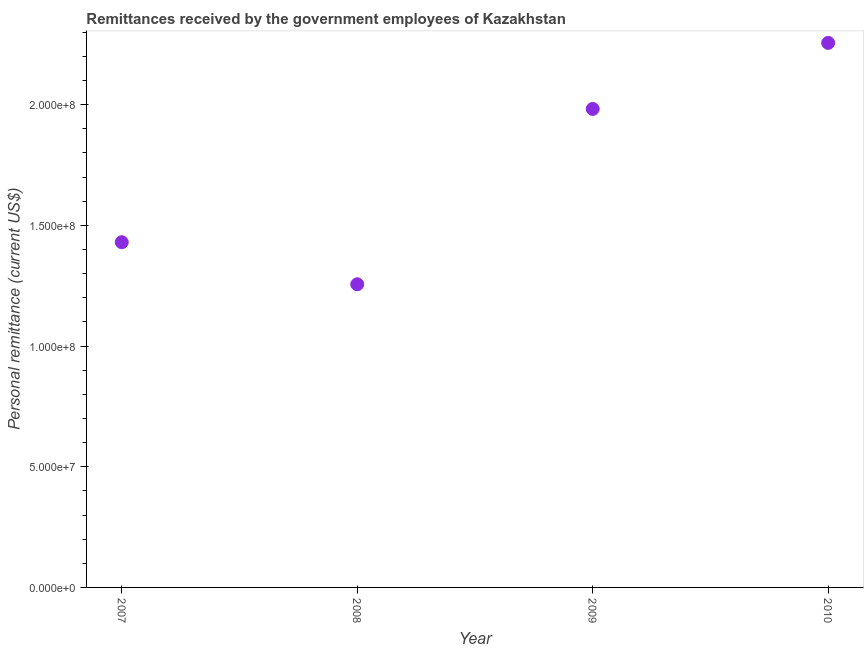What is the personal remittances in 2007?
Keep it short and to the point. 1.43e+08. Across all years, what is the maximum personal remittances?
Your answer should be very brief. 2.26e+08. Across all years, what is the minimum personal remittances?
Your answer should be very brief. 1.26e+08. What is the sum of the personal remittances?
Make the answer very short. 6.92e+08. What is the difference between the personal remittances in 2007 and 2010?
Provide a succinct answer. -8.26e+07. What is the average personal remittances per year?
Ensure brevity in your answer.  1.73e+08. What is the median personal remittances?
Your answer should be compact. 1.71e+08. In how many years, is the personal remittances greater than 80000000 US$?
Make the answer very short. 4. Do a majority of the years between 2009 and 2007 (inclusive) have personal remittances greater than 160000000 US$?
Your response must be concise. No. What is the ratio of the personal remittances in 2008 to that in 2010?
Provide a short and direct response. 0.56. What is the difference between the highest and the second highest personal remittances?
Offer a very short reply. 2.74e+07. Is the sum of the personal remittances in 2007 and 2009 greater than the maximum personal remittances across all years?
Your response must be concise. Yes. What is the difference between the highest and the lowest personal remittances?
Keep it short and to the point. 1.00e+08. Does the personal remittances monotonically increase over the years?
Ensure brevity in your answer.  No. How many years are there in the graph?
Provide a succinct answer. 4. What is the difference between two consecutive major ticks on the Y-axis?
Provide a short and direct response. 5.00e+07. Are the values on the major ticks of Y-axis written in scientific E-notation?
Provide a succinct answer. Yes. Does the graph contain grids?
Your answer should be compact. No. What is the title of the graph?
Make the answer very short. Remittances received by the government employees of Kazakhstan. What is the label or title of the X-axis?
Make the answer very short. Year. What is the label or title of the Y-axis?
Offer a very short reply. Personal remittance (current US$). What is the Personal remittance (current US$) in 2007?
Ensure brevity in your answer.  1.43e+08. What is the Personal remittance (current US$) in 2008?
Your answer should be very brief. 1.26e+08. What is the Personal remittance (current US$) in 2009?
Your answer should be very brief. 1.98e+08. What is the Personal remittance (current US$) in 2010?
Provide a short and direct response. 2.26e+08. What is the difference between the Personal remittance (current US$) in 2007 and 2008?
Your answer should be compact. 1.74e+07. What is the difference between the Personal remittance (current US$) in 2007 and 2009?
Offer a terse response. -5.52e+07. What is the difference between the Personal remittance (current US$) in 2007 and 2010?
Give a very brief answer. -8.26e+07. What is the difference between the Personal remittance (current US$) in 2008 and 2009?
Your answer should be compact. -7.26e+07. What is the difference between the Personal remittance (current US$) in 2008 and 2010?
Provide a short and direct response. -1.00e+08. What is the difference between the Personal remittance (current US$) in 2009 and 2010?
Offer a very short reply. -2.74e+07. What is the ratio of the Personal remittance (current US$) in 2007 to that in 2008?
Your answer should be compact. 1.14. What is the ratio of the Personal remittance (current US$) in 2007 to that in 2009?
Provide a succinct answer. 0.72. What is the ratio of the Personal remittance (current US$) in 2007 to that in 2010?
Your response must be concise. 0.63. What is the ratio of the Personal remittance (current US$) in 2008 to that in 2009?
Your response must be concise. 0.63. What is the ratio of the Personal remittance (current US$) in 2008 to that in 2010?
Offer a terse response. 0.56. What is the ratio of the Personal remittance (current US$) in 2009 to that in 2010?
Ensure brevity in your answer.  0.88. 